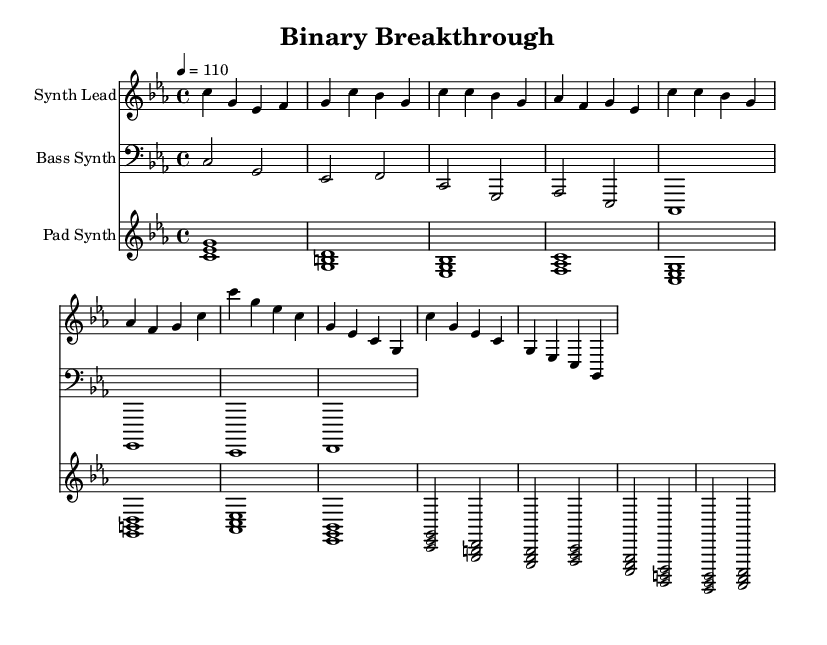What is the key signature of this music? The key signature is C minor, which has three flats: B flat, E flat, and A flat. This is indicated at the beginning of the staff.
Answer: C minor What is the time signature of this piece? The time signature is 4/4, meaning there are four beats per measure and the quarter note gets one beat. This is shown right after the key signature.
Answer: 4/4 What is the tempo marking of the music? The tempo marking is 4 equals 110, which indicates that a quarter note should be played at a rate of 110 beats per minute. This information is displayed at the start, near the key and time signatures.
Answer: 110 What instruments are featured in the score? The score features Synth Lead, Bass Synth, and Pad Synth, as indicated by the instrument names above each staff.
Answer: Synth Lead, Bass Synth, Pad Synth How many measures does the Pad Synth section contain? The Pad Synth section contains ten measures, which can be counted from the leftmost measure in the staff to the rightmost measure.
Answer: 10 What intervals are played in the first measure of the Pad Synth? The intervals in the first measure of the Pad Synth are a minor sixth (C to E flat), a perfect fourth (E flat to G), and a perfect fifth (C to G), indicated by the simultaneous notes.
Answer: Minor sixth, perfect fourth, perfect fifth How many notes are in the Synth Lead's first phrase? The first phrase of the Synth Lead consists of eight notes, which can be counted directly from the beginning of the melody to the end of the first measure.
Answer: 8 